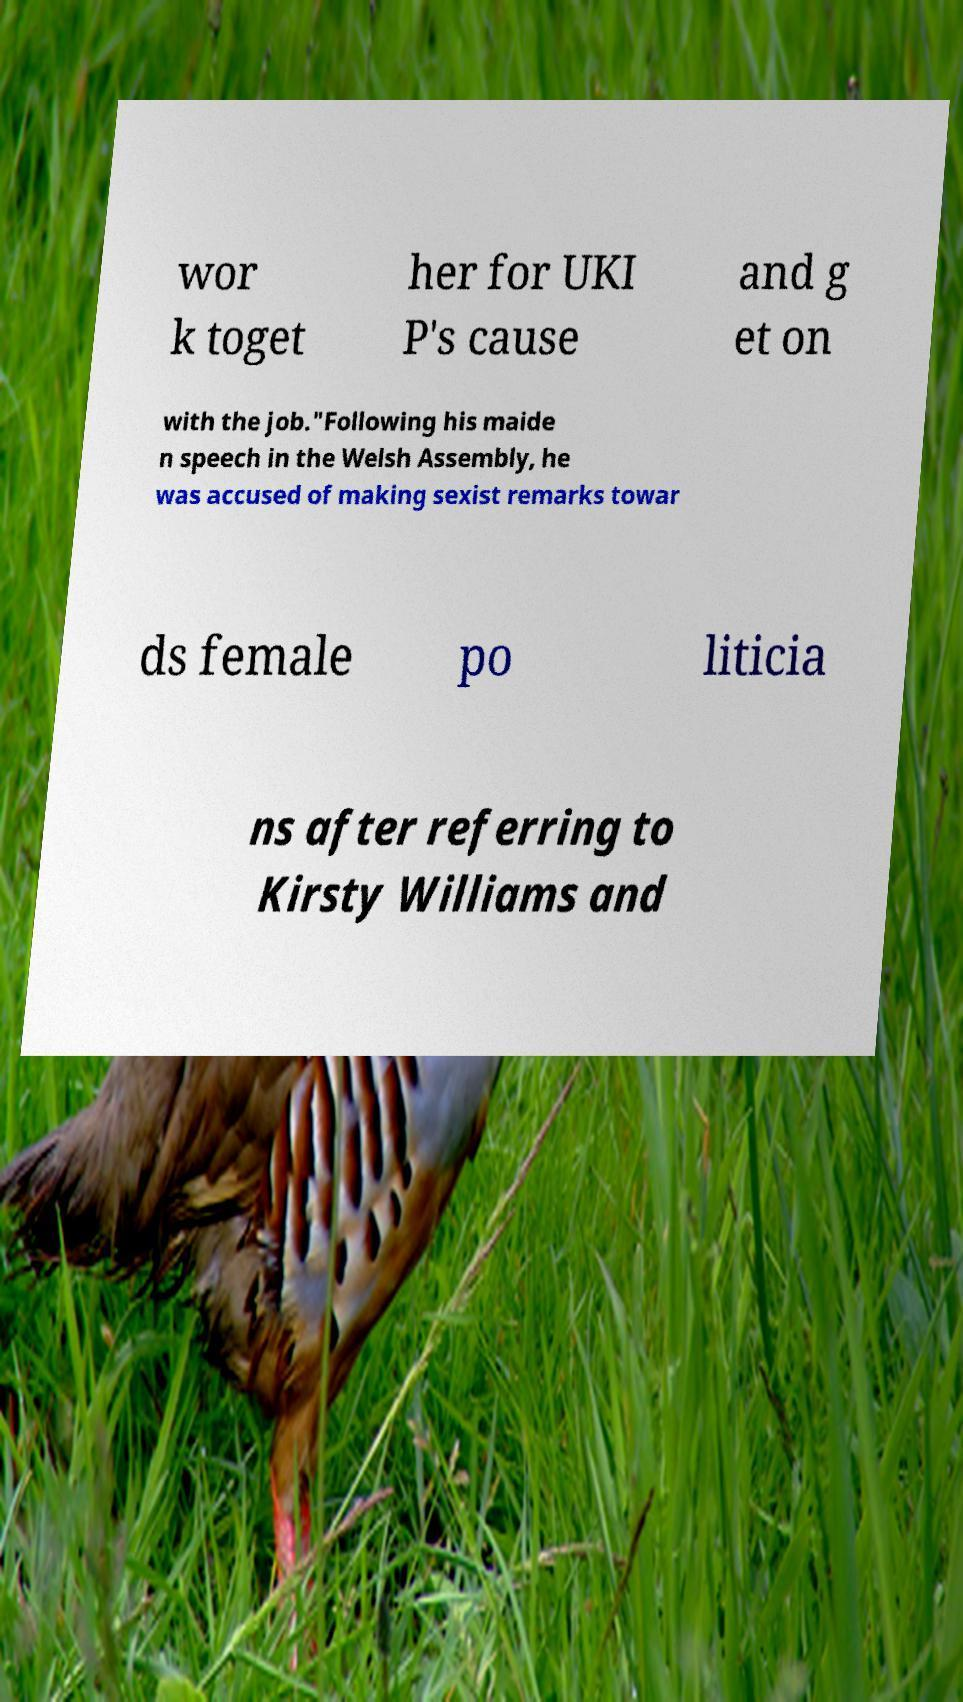For documentation purposes, I need the text within this image transcribed. Could you provide that? wor k toget her for UKI P's cause and g et on with the job."Following his maide n speech in the Welsh Assembly, he was accused of making sexist remarks towar ds female po liticia ns after referring to Kirsty Williams and 